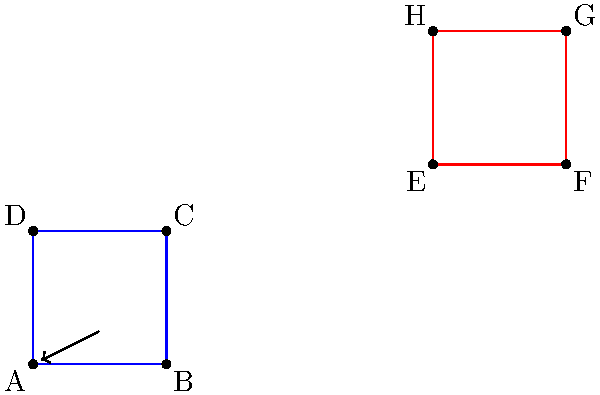In a tribute to Jim Carrey's iconic role in "The Mask," we're translating The Mask's zoot suit pattern across a coordinate plane. The original suit pattern is represented by the blue square ABCD, and it has been translated to the red square EFGH. If point A is at (0,0) and point E is at (6,3), what is the translation vector that moves the suit pattern from its original position to its new position? Let's approach this step-by-step:

1) The translation vector is the vector that moves any point on the original shape to its corresponding point on the translated shape.

2) We're given that point A is at (0,0) and point E is at (6,3).

3) To find the translation vector, we need to subtract the coordinates of the original point from the coordinates of the translated point:

   $$(x_E, y_E) - (x_A, y_A) = (6, 3) - (0, 0)$$

4) Simplifying:

   $$(6-0, 3-0) = (6, 3)$$

5) Therefore, the translation vector is $\langle 6, 3 \rangle$.

6) This means that every point of the original suit pattern (ABCD) has been moved 6 units to the right and 3 units up to create the new pattern (EFGH).

7) We can verify this by checking any other corresponding points. For example, if B is at (2,0), then F should be at (8,3), which it is.
Answer: $\langle 6, 3 \rangle$ 